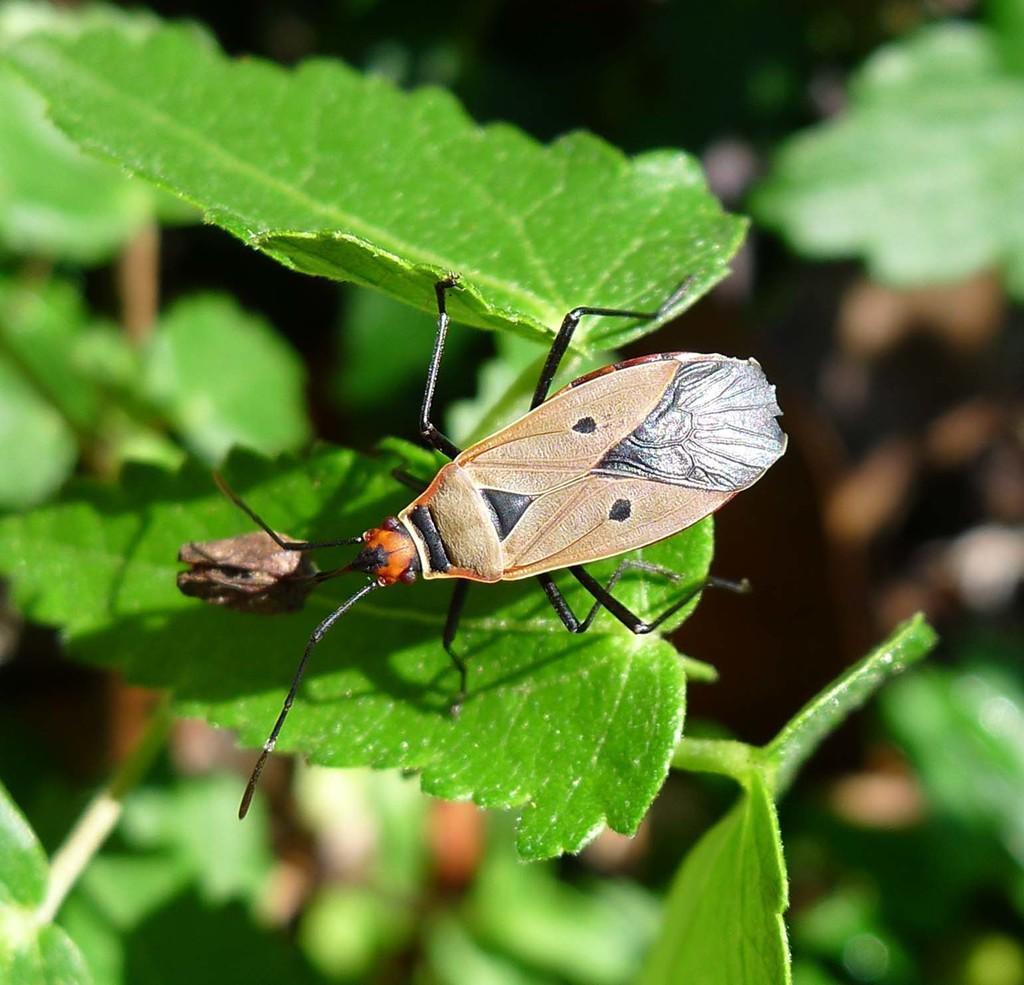Describe this image in one or two sentences. In this there is a fly which is standing on the leaf. On the left there is a plant. 